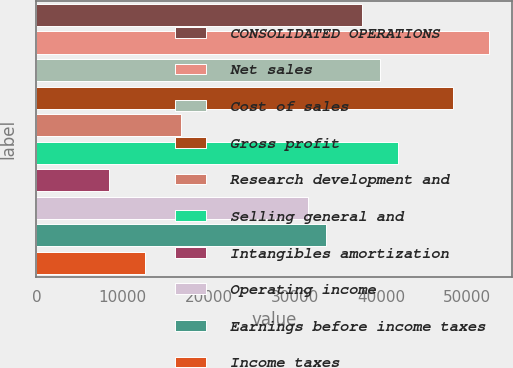Convert chart to OTSL. <chart><loc_0><loc_0><loc_500><loc_500><bar_chart><fcel>CONSOLIDATED OPERATIONS<fcel>Net sales<fcel>Cost of sales<fcel>Gross profit<fcel>Research development and<fcel>Selling general and<fcel>Intangibles amortization<fcel>Operating income<fcel>Earnings before income taxes<fcel>Income taxes<nl><fcel>37799.5<fcel>52499<fcel>39899.4<fcel>48299.1<fcel>16800.2<fcel>41999.3<fcel>8400.44<fcel>31499.7<fcel>33599.6<fcel>12600.3<nl></chart> 